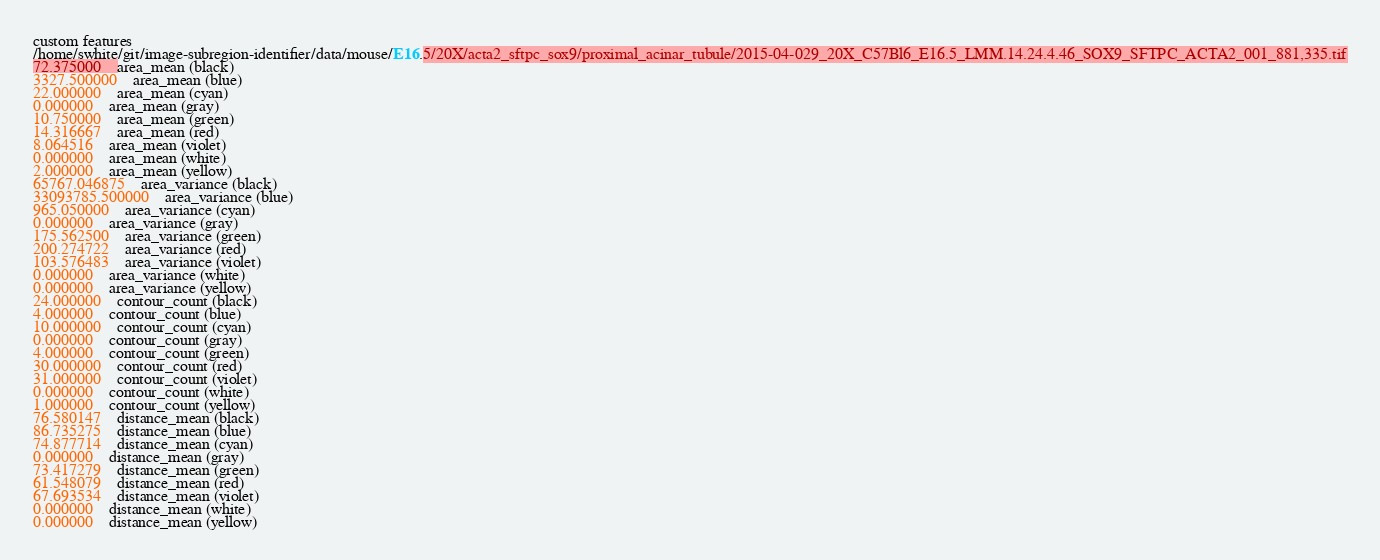<code> <loc_0><loc_0><loc_500><loc_500><_SML_>custom features
/home/swhite/git/image-subregion-identifier/data/mouse/E16.5/20X/acta2_sftpc_sox9/proximal_acinar_tubule/2015-04-029_20X_C57Bl6_E16.5_LMM.14.24.4.46_SOX9_SFTPC_ACTA2_001_881,335.tif
72.375000	area_mean (black)
3327.500000	area_mean (blue)
22.000000	area_mean (cyan)
0.000000	area_mean (gray)
10.750000	area_mean (green)
14.316667	area_mean (red)
8.064516	area_mean (violet)
0.000000	area_mean (white)
2.000000	area_mean (yellow)
65767.046875	area_variance (black)
33093785.500000	area_variance (blue)
965.050000	area_variance (cyan)
0.000000	area_variance (gray)
175.562500	area_variance (green)
200.274722	area_variance (red)
103.576483	area_variance (violet)
0.000000	area_variance (white)
0.000000	area_variance (yellow)
24.000000	contour_count (black)
4.000000	contour_count (blue)
10.000000	contour_count (cyan)
0.000000	contour_count (gray)
4.000000	contour_count (green)
30.000000	contour_count (red)
31.000000	contour_count (violet)
0.000000	contour_count (white)
1.000000	contour_count (yellow)
76.580147	distance_mean (black)
86.735275	distance_mean (blue)
74.877714	distance_mean (cyan)
0.000000	distance_mean (gray)
73.417279	distance_mean (green)
61.548079	distance_mean (red)
67.693534	distance_mean (violet)
0.000000	distance_mean (white)
0.000000	distance_mean (yellow)</code> 